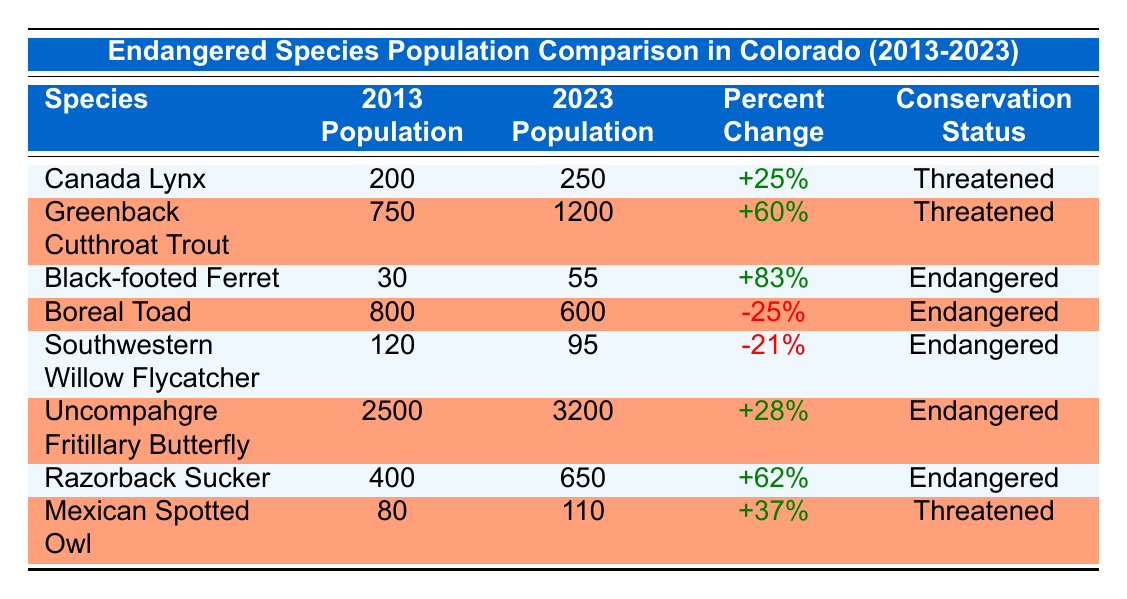What was the population of the Canada Lynx in 2013? The table shows that the 2013 population of the Canada Lynx is listed as 200.
Answer: 200 Which species had the largest increase in population between 2013 and 2023? To determine this, we need to compare the percent changes for each species. The Black-footed Ferret shows the highest percent increase of +83%.
Answer: Black-footed Ferret Is the population of the Boreal Toad decreasing or increasing? The table lists the 2013 population of the Boreal Toad as 800 and the 2023 population as 600, which indicates a decrease.
Answer: Decreasing What is the total population change for all the species combined in 2023 compared to 2013? We calculate the total population for 2013 and 2023. Sum for 2013 is (200 + 750 + 30 + 800 + 120 + 2500 + 400 + 80) = 3880, and for 2023 is (250 + 1200 + 55 + 600 + 95 + 3200 + 650 + 110) = 5160. The total change is 5160 - 3880 = 1280.
Answer: 1280 Are there any species with a conservation status of "Threatened" that showed a population increase? We check the species listed as "Threatened" and their population changes. The Canada Lynx and Greenback Cutthroat Trout both had positive percent changes, indicating they increased in population.
Answer: Yes What is the average population change for all endangered species over the decade? To find the average, we look at the percent changes for the endangered species: +83% (Black-footed Ferret), -25% (Boreal Toad), -21% (Southwestern Willow Flycatcher), +28% (Uncompahgre Fritillary Butterfly), +62% (Razorback Sucker). Summing these gives 83 - 25 - 21 + 28 + 62 = 127. There are 5 species, so the average is 127/5 = 25.4%.
Answer: 25.4% Which species showed a larger decrease in population: Boreal Toad or Southwestern Willow Flycatcher? The Boreal Toad has a percent change of -25%, and the Southwestern Willow Flycatcher has a percent change of -21%. Since -25% is lower, the Boreal Toad shows a larger decrease.
Answer: Boreal Toad How many species increased their populations over the decade? From the table, we identify the species with positive percent changes: Canada Lynx, Greenback Cutthroat Trout, Black-footed Ferret, Uncompahgre Fritillary Butterfly, Razorback Sucker, and Mexican Spotted Owl, totaling 6 species.
Answer: 6 